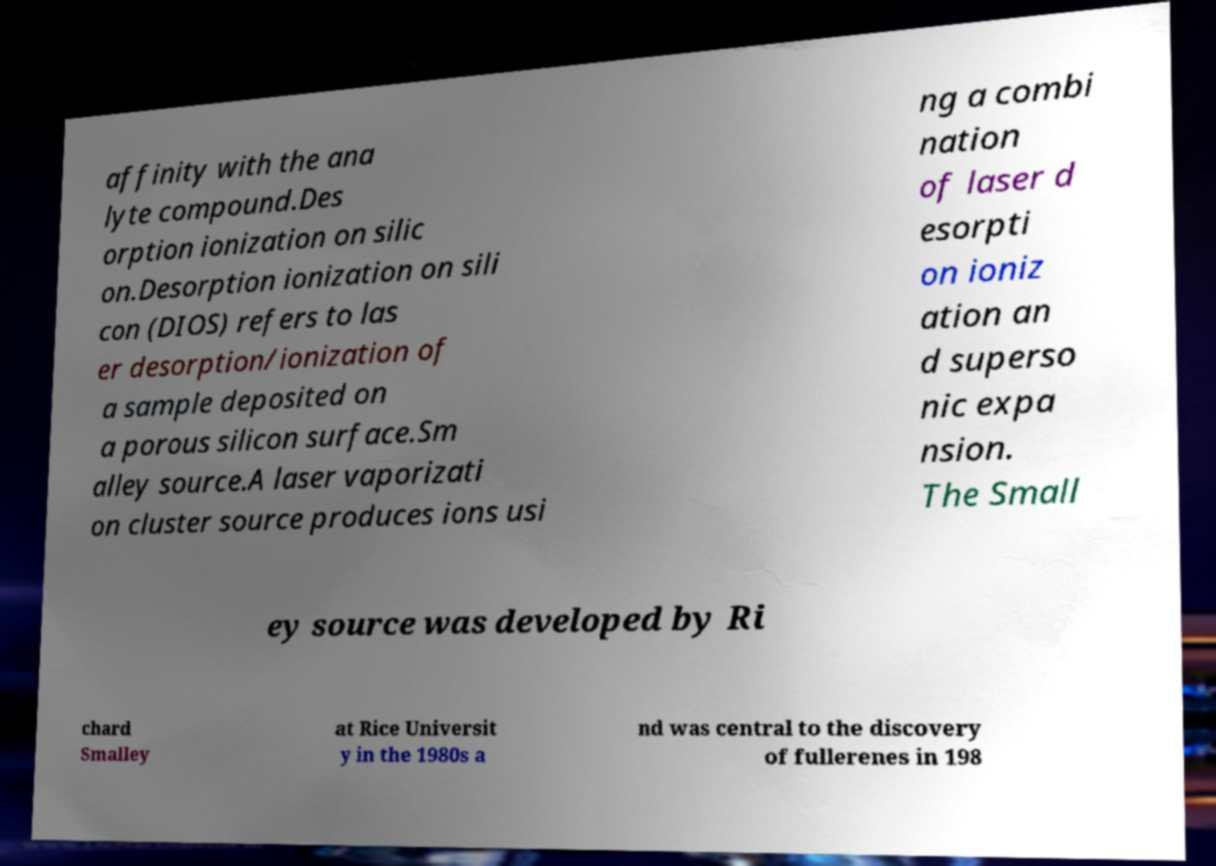Can you read and provide the text displayed in the image?This photo seems to have some interesting text. Can you extract and type it out for me? affinity with the ana lyte compound.Des orption ionization on silic on.Desorption ionization on sili con (DIOS) refers to las er desorption/ionization of a sample deposited on a porous silicon surface.Sm alley source.A laser vaporizati on cluster source produces ions usi ng a combi nation of laser d esorpti on ioniz ation an d superso nic expa nsion. The Small ey source was developed by Ri chard Smalley at Rice Universit y in the 1980s a nd was central to the discovery of fullerenes in 198 